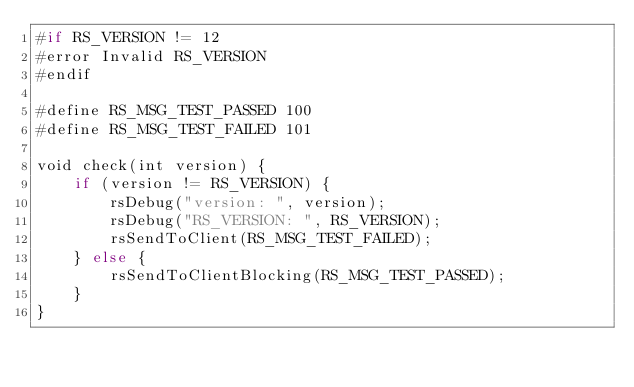Convert code to text. <code><loc_0><loc_0><loc_500><loc_500><_Rust_>#if RS_VERSION != 12
#error Invalid RS_VERSION
#endif

#define RS_MSG_TEST_PASSED 100
#define RS_MSG_TEST_FAILED 101

void check(int version) {
    if (version != RS_VERSION) {
        rsDebug("version: ", version);
        rsDebug("RS_VERSION: ", RS_VERSION);
        rsSendToClient(RS_MSG_TEST_FAILED);
    } else {
        rsSendToClientBlocking(RS_MSG_TEST_PASSED);
    }
}

</code> 